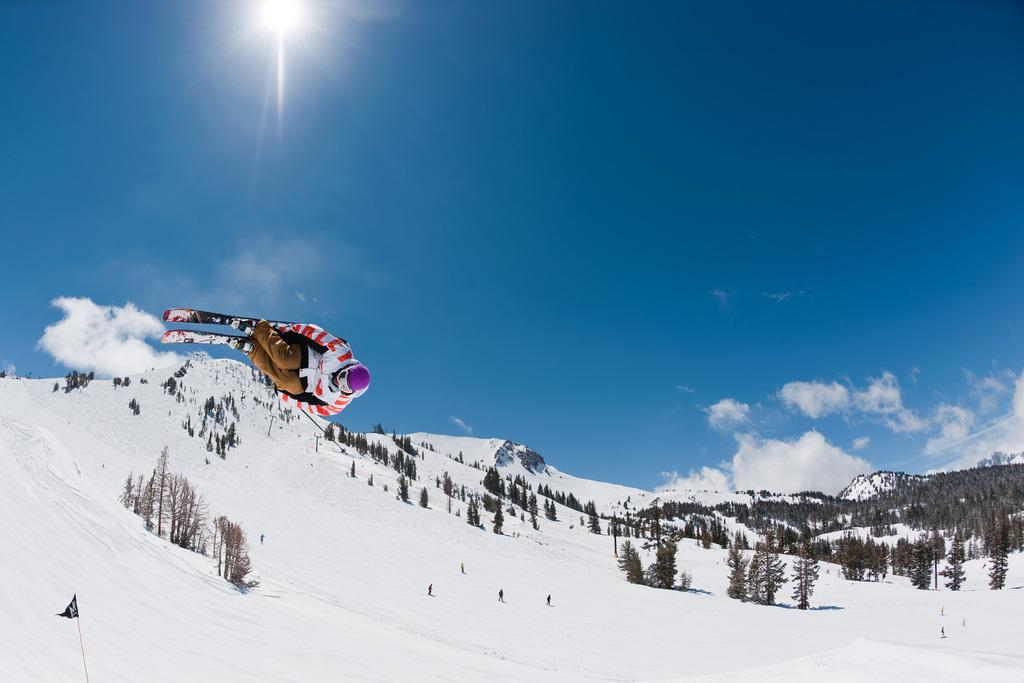What is the main subject of the image? There is a person in the image. What is the person wearing? The person is wearing a white and red dress. What activity is the person engaged in? The person is skiing. What can be seen in the background of the image? There are trees and snow in the background of the image. How many books can be seen on the person's head in the image? There are no books present in the image; the person is skiing and wearing a white and red dress. Are there any women in the image? The provided facts do not mention the gender of the person in the image, so we cannot definitively answer whether there are any women in the image. 